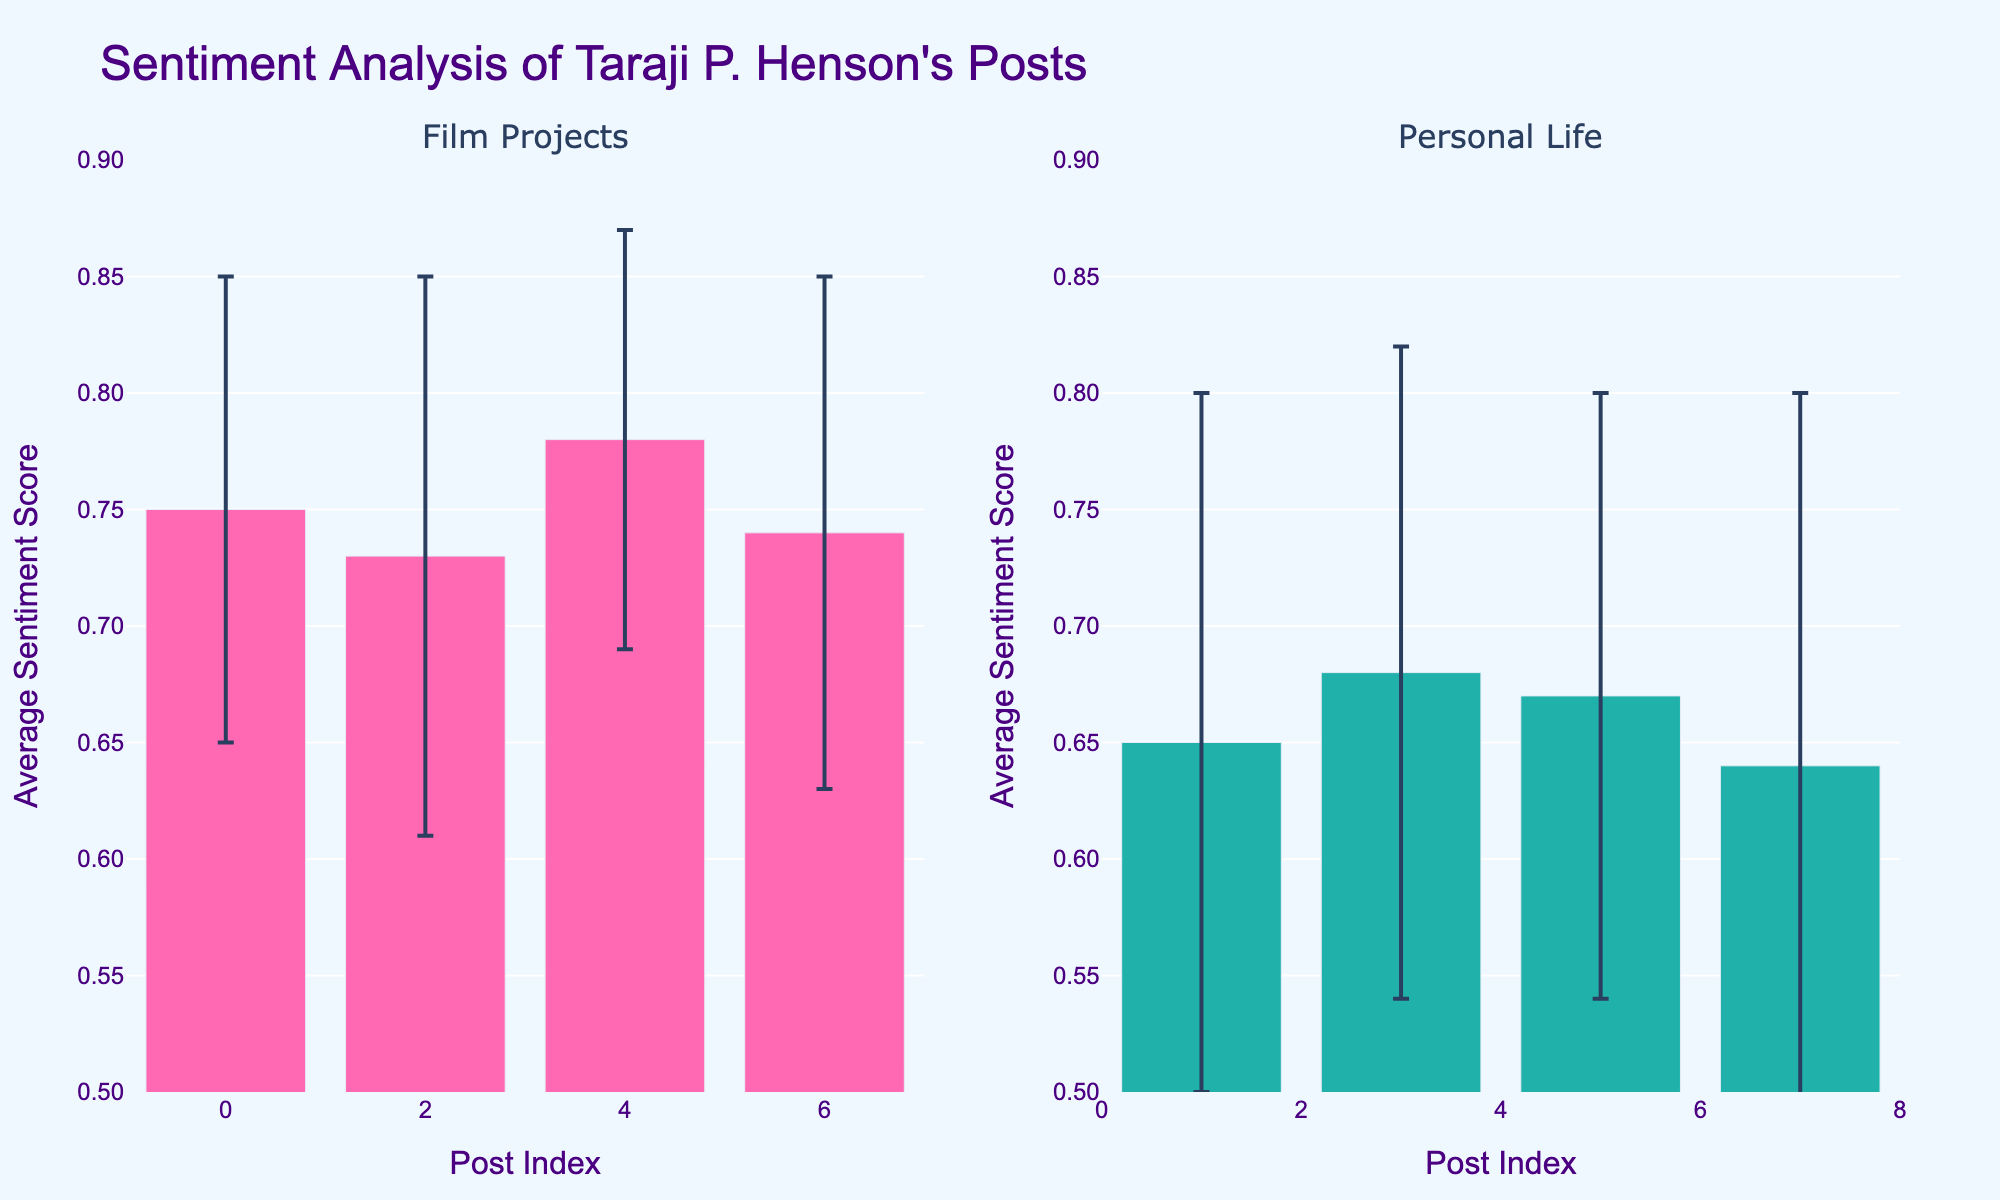What's the title of the figure? The title is usually at the top of the figure. In this case, the title is "Sentiment Analysis of Taraji P. Henson's Posts".
Answer: Sentiment Analysis of Taraji P. Henson's Posts How many subplots are there and what do they represent? There are two subplots as seen by the titles above each plot. The first subplot represents "Film Projects" and the second represents "Personal Life".
Answer: Two; "Film Projects" and "Personal Life" What is the range of the y-axis in this figure? The range of the y-axis can be seen by looking at the axis labels. The range is from 0.5 to 0.9.
Answer: 0.5 to 0.9 Which content type has a higher average sentiment score range, and what are the approximate values? By comparing the heights of the bars in both subplots, Film Projects generally have higher average sentiment scores ranging from approximately 0.73 to 0.78.
Answer: Film Projects; approximately 0.73 to 0.78 Compare the sentiment scores for Film Projects and Personal Life. Which one shows more variation based on error bars? More variation is seen in the error bars for Personal Life, which are longer compared to the error bars for Film Projects, indicating more variability in the data.
Answer: Personal Life What is the color used for the bars representing "Film Projects"? The color of the bars can be identified from the visual representation, which is pink.
Answer: Pink What is the minimum average sentiment score for Personal Life? By looking at the height of the bars in the Personal Life subplot, the minimum average sentiment score is approximately 0.64.
Answer: Approximately 0.64 Calculate the average of the sentiment scores for Film Projects. The average sentiment scores for Film Projects are 0.75, 0.73, 0.78, and 0.74. Summing these values (0.75 + 0.73 + 0.78 + 0.74) results in 3.00. Dividing by 4 gives an average of 0.75.
Answer: 0.75 Of the average sentiment scores provided, what is the highest recorded for "Personal Life" posts? By examining the heights of the bars for Personal Life, the highest average sentiment score is approximately 0.68.
Answer: Approximately 0.68 Among the two content types, which one tends to have sentiment scores clustered closer to a specific value, and what could indicate this visually? Film Projects tend to have sentiment scores clustered closer to a specific value since their individual sentiment scores are very close to each other, and the error bars are shorter, indicating less variability.
Answer: Film Projects What is the average sentiment score difference between Film Projects and Personal Life? The average sentiment scores for Film Projects are 0.75, 0.73, 0.78, and 0.74, and for Personal Life are 0.65, 0.68, 0.67, and 0.64. The average for Film Projects is 0.75, and for Personal Life is 0.66. The difference is 0.75 - 0.66 which is 0.09.
Answer: 0.09 